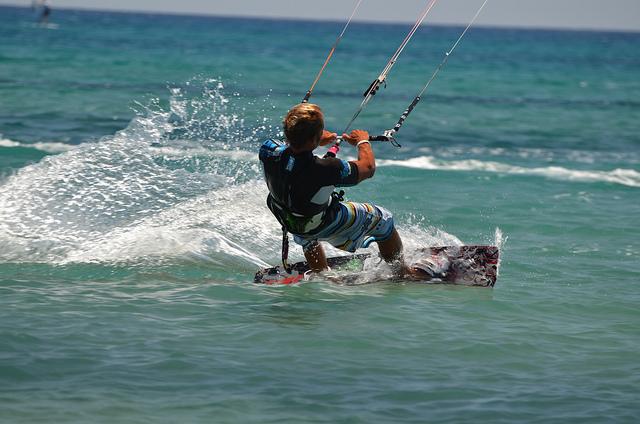How many cables come off the top of the bar?
Give a very brief answer. 3. Is the man about to fly?
Give a very brief answer. Yes. What is the man holding onto?
Answer briefly. Parasail. 